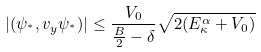Convert formula to latex. <formula><loc_0><loc_0><loc_500><loc_500>| ( \psi _ { ^ { * } } , v _ { y } \psi _ { ^ { * } } ) | \leq \frac { V _ { 0 } } { \frac { B } { 2 } - \delta } \sqrt { 2 ( E _ { \kappa } ^ { \alpha } + V _ { 0 } ) }</formula> 